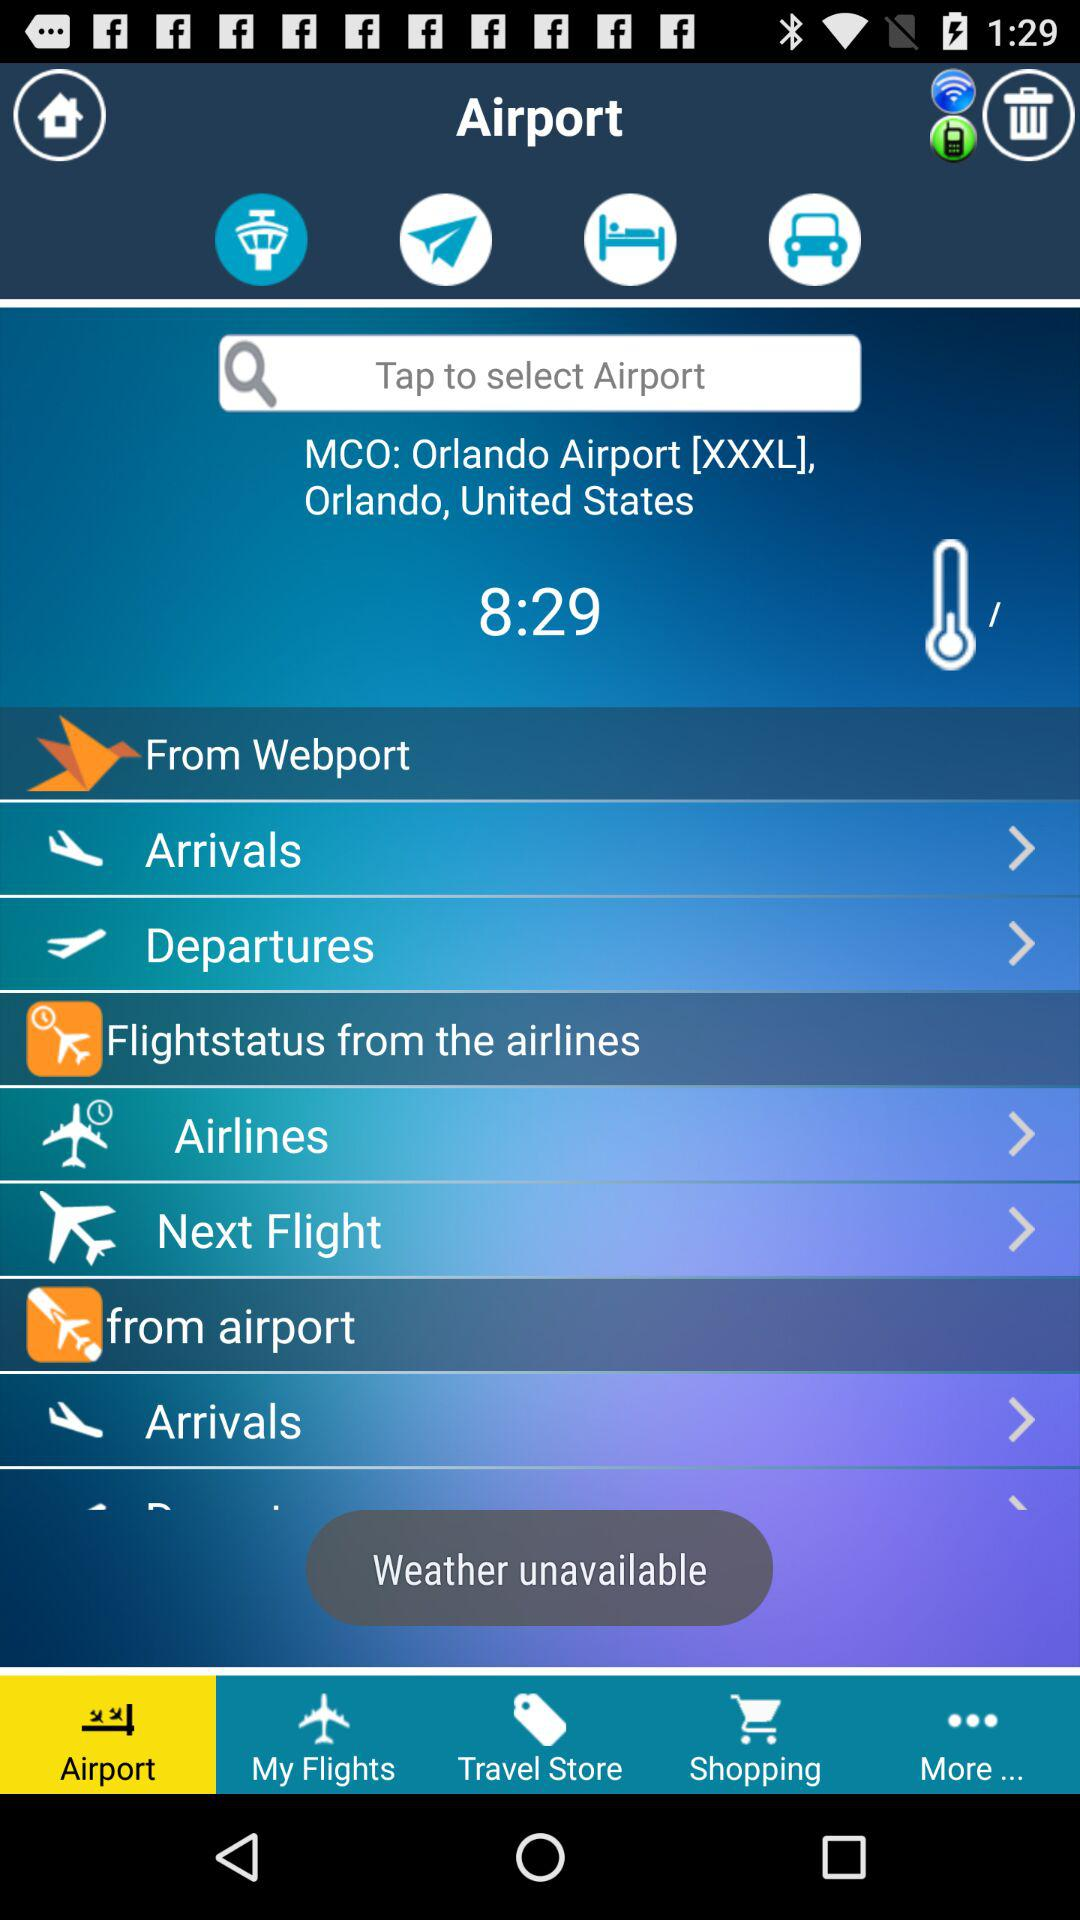What is the name of the airport? The name of the airport is "Orlando Airport". 